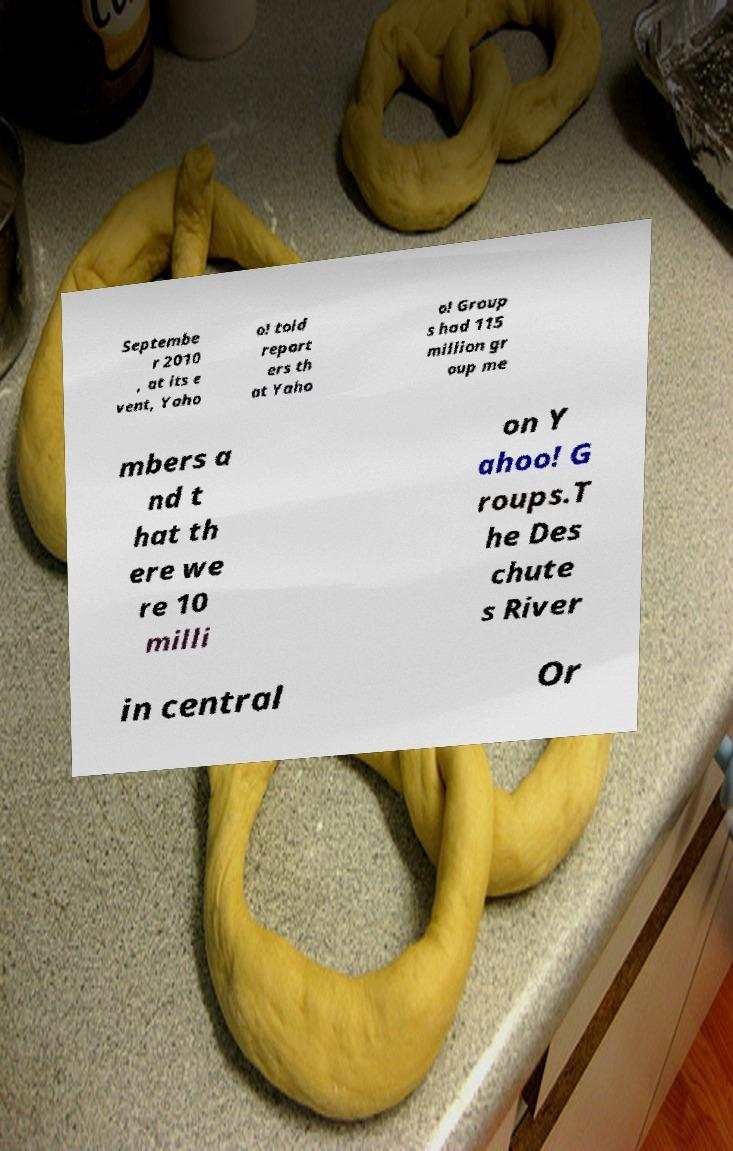Please identify and transcribe the text found in this image. Septembe r 2010 , at its e vent, Yaho o! told report ers th at Yaho o! Group s had 115 million gr oup me mbers a nd t hat th ere we re 10 milli on Y ahoo! G roups.T he Des chute s River in central Or 